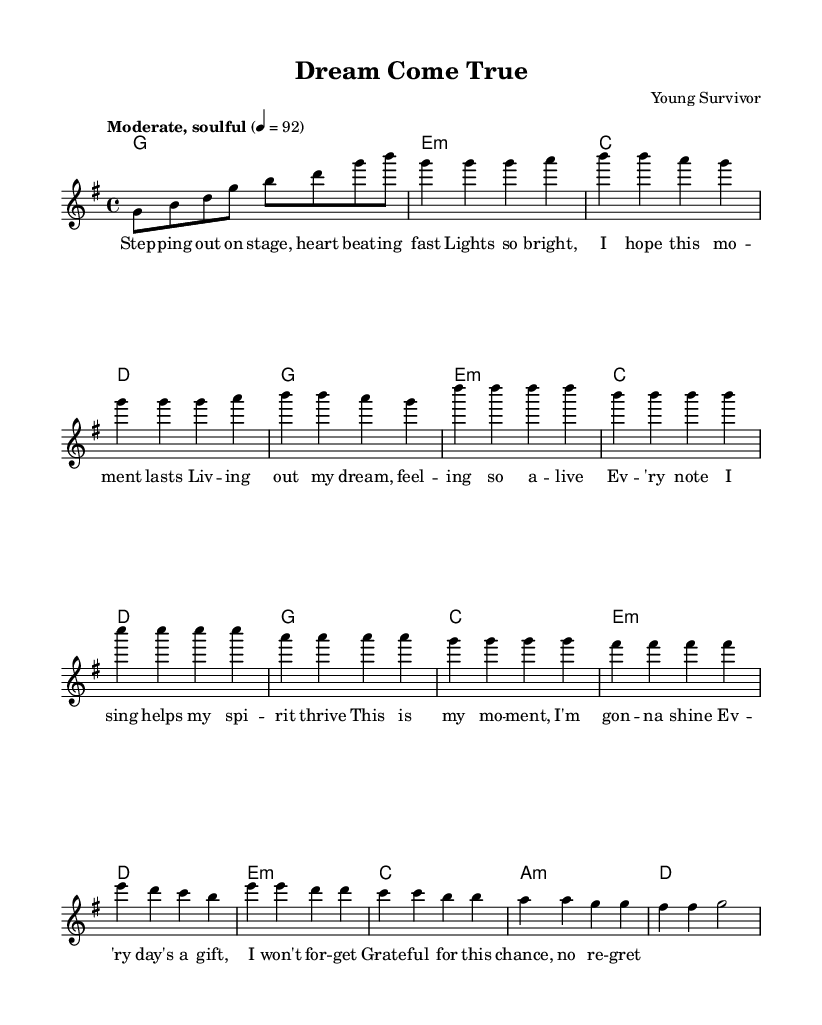What is the key signature of this music? The key signature is G major, which has one sharp (F-sharp). This can be determined by looking at the key signature marker at the beginning of the piece, indicating the tonality.
Answer: G major What is the time signature of this music? The time signature is 4/4, indicated by the fraction next to the clef at the beginning of the score. This means there are four beats per measure, and the quarter note gets one beat.
Answer: 4/4 What is the tempo marking for this piece? The tempo marking is "Moderate, soulful," and it is set to 92 beats per minute. This suggests a laid-back yet rhythmically engaging pace for the performance, essential for rhythm and blues music.
Answer: Moderate, soulful How many bars are in the chorus section? The chorus section consists of 8 bars, which can be counted by identifying the only section labeled "Chorus" in the score and ensuring to include all measures listed there.
Answer: 8 bars Which chord follows the first line of the verse? The chord following the first line of the verse is G major. This can be inferred by looking at the chord symbols that are indicated above the lyrics in the first part of the verse.
Answer: G major What emotion does the bridge evoke compared to the other sections? The bridge evokes a reflective and slightly somber emotion; the lyrics and the harmonic movement (using minor chords) contribute to this feeling as it contrasts with the more uplifting vibe of the verse and chorus. This can be deduced by analyzing the lyrics and the transition in harmonies used in this section.
Answer: Reflective, somber What melodic interval is primarily used in the verses? The primary melodic interval used in the verses is a stepwise motion (seconds). This can be established by looking at the notes in the melody for the verse, which generally move to the next note in the scale or remain in close proximity to one another.
Answer: Stepwise motion 